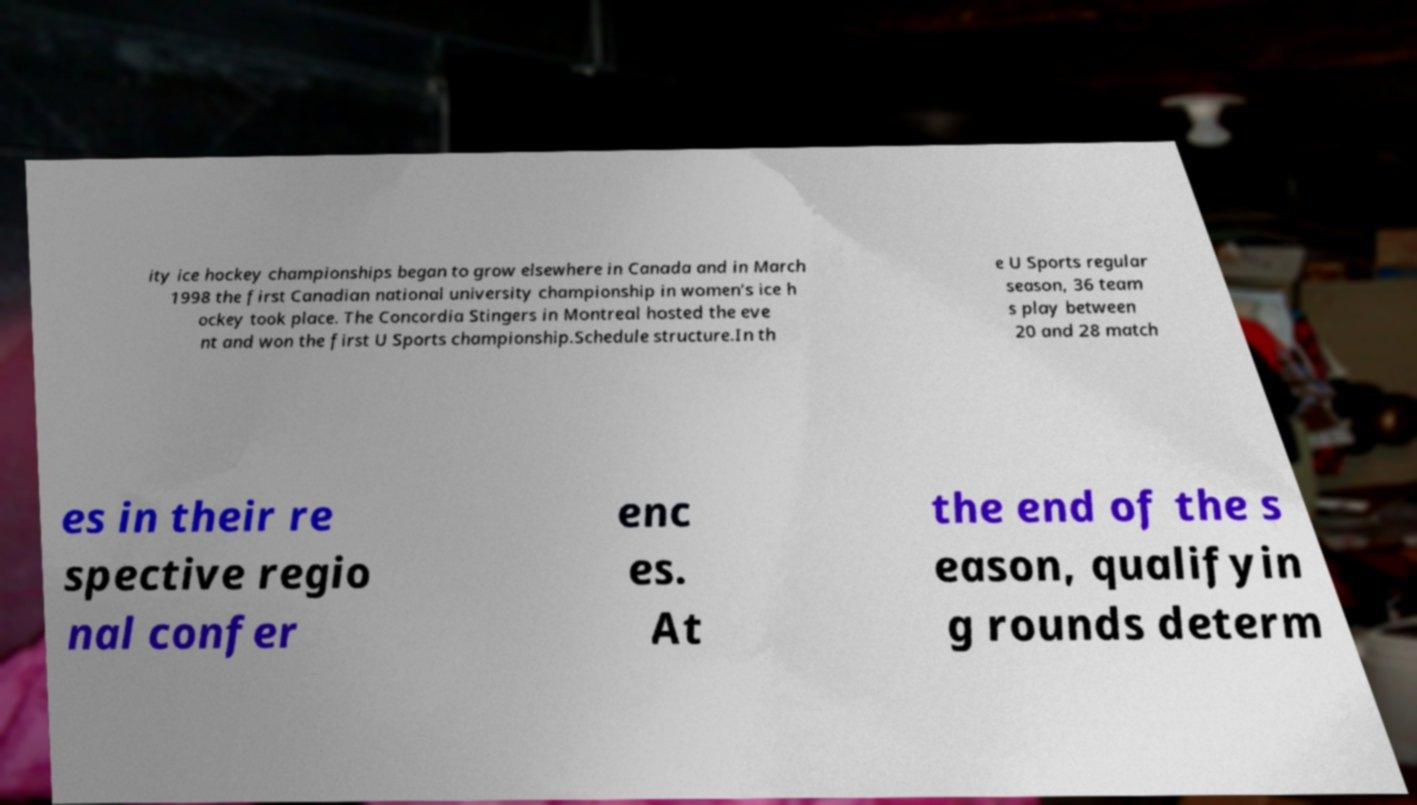I need the written content from this picture converted into text. Can you do that? ity ice hockey championships began to grow elsewhere in Canada and in March 1998 the first Canadian national university championship in women’s ice h ockey took place. The Concordia Stingers in Montreal hosted the eve nt and won the first U Sports championship.Schedule structure.In th e U Sports regular season, 36 team s play between 20 and 28 match es in their re spective regio nal confer enc es. At the end of the s eason, qualifyin g rounds determ 